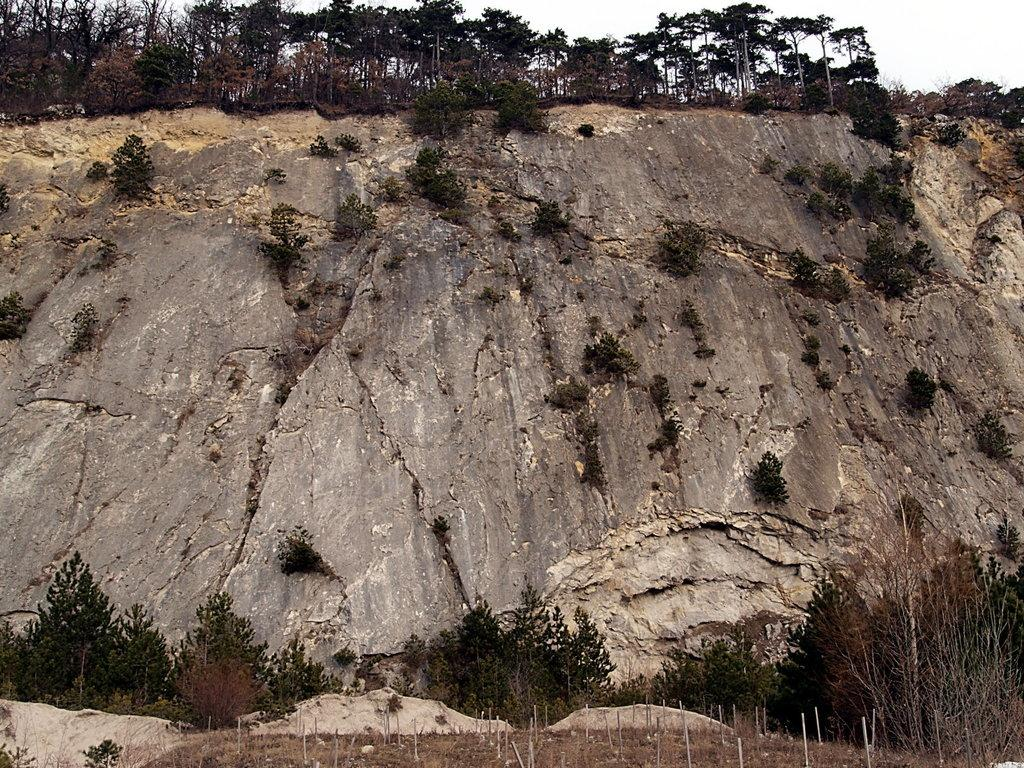What type of vegetation can be seen in the image? There is a group of trees and plants visible in the image. What geographical feature is present in the image? There is a hill in the image. What type of natural objects can be seen in the image? Rocks are present in the image. What else can be seen in the image besides the trees and plants? There are poles in the image. What is visible at the top of the image? The sky is visible in the image. How does the society in the image interact with the calculator? There is no society or calculator present in the image. Can you tell me how fast the runners are going in the image? There are no runners present in the image. 